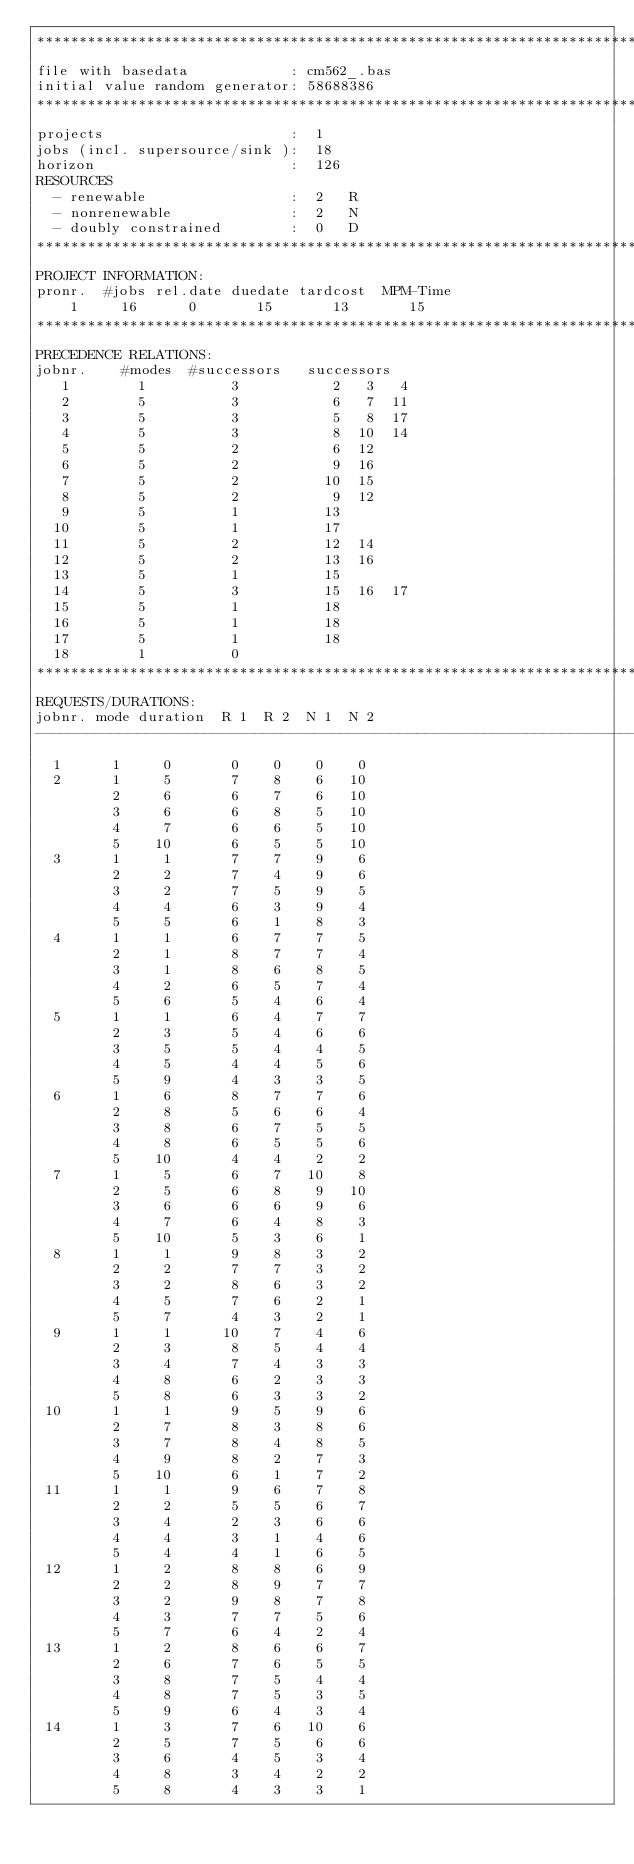<code> <loc_0><loc_0><loc_500><loc_500><_ObjectiveC_>************************************************************************
file with basedata            : cm562_.bas
initial value random generator: 58688386
************************************************************************
projects                      :  1
jobs (incl. supersource/sink ):  18
horizon                       :  126
RESOURCES
  - renewable                 :  2   R
  - nonrenewable              :  2   N
  - doubly constrained        :  0   D
************************************************************************
PROJECT INFORMATION:
pronr.  #jobs rel.date duedate tardcost  MPM-Time
    1     16      0       15       13       15
************************************************************************
PRECEDENCE RELATIONS:
jobnr.    #modes  #successors   successors
   1        1          3           2   3   4
   2        5          3           6   7  11
   3        5          3           5   8  17
   4        5          3           8  10  14
   5        5          2           6  12
   6        5          2           9  16
   7        5          2          10  15
   8        5          2           9  12
   9        5          1          13
  10        5          1          17
  11        5          2          12  14
  12        5          2          13  16
  13        5          1          15
  14        5          3          15  16  17
  15        5          1          18
  16        5          1          18
  17        5          1          18
  18        1          0        
************************************************************************
REQUESTS/DURATIONS:
jobnr. mode duration  R 1  R 2  N 1  N 2
------------------------------------------------------------------------
  1      1     0       0    0    0    0
  2      1     5       7    8    6   10
         2     6       6    7    6   10
         3     6       6    8    5   10
         4     7       6    6    5   10
         5    10       6    5    5   10
  3      1     1       7    7    9    6
         2     2       7    4    9    6
         3     2       7    5    9    5
         4     4       6    3    9    4
         5     5       6    1    8    3
  4      1     1       6    7    7    5
         2     1       8    7    7    4
         3     1       8    6    8    5
         4     2       6    5    7    4
         5     6       5    4    6    4
  5      1     1       6    4    7    7
         2     3       5    4    6    6
         3     5       5    4    4    5
         4     5       4    4    5    6
         5     9       4    3    3    5
  6      1     6       8    7    7    6
         2     8       5    6    6    4
         3     8       6    7    5    5
         4     8       6    5    5    6
         5    10       4    4    2    2
  7      1     5       6    7   10    8
         2     5       6    8    9   10
         3     6       6    6    9    6
         4     7       6    4    8    3
         5    10       5    3    6    1
  8      1     1       9    8    3    2
         2     2       7    7    3    2
         3     2       8    6    3    2
         4     5       7    6    2    1
         5     7       4    3    2    1
  9      1     1      10    7    4    6
         2     3       8    5    4    4
         3     4       7    4    3    3
         4     8       6    2    3    3
         5     8       6    3    3    2
 10      1     1       9    5    9    6
         2     7       8    3    8    6
         3     7       8    4    8    5
         4     9       8    2    7    3
         5    10       6    1    7    2
 11      1     1       9    6    7    8
         2     2       5    5    6    7
         3     4       2    3    6    6
         4     4       3    1    4    6
         5     4       4    1    6    5
 12      1     2       8    8    6    9
         2     2       8    9    7    7
         3     2       9    8    7    8
         4     3       7    7    5    6
         5     7       6    4    2    4
 13      1     2       8    6    6    7
         2     6       7    6    5    5
         3     8       7    5    4    4
         4     8       7    5    3    5
         5     9       6    4    3    4
 14      1     3       7    6   10    6
         2     5       7    5    6    6
         3     6       4    5    3    4
         4     8       3    4    2    2
         5     8       4    3    3    1</code> 